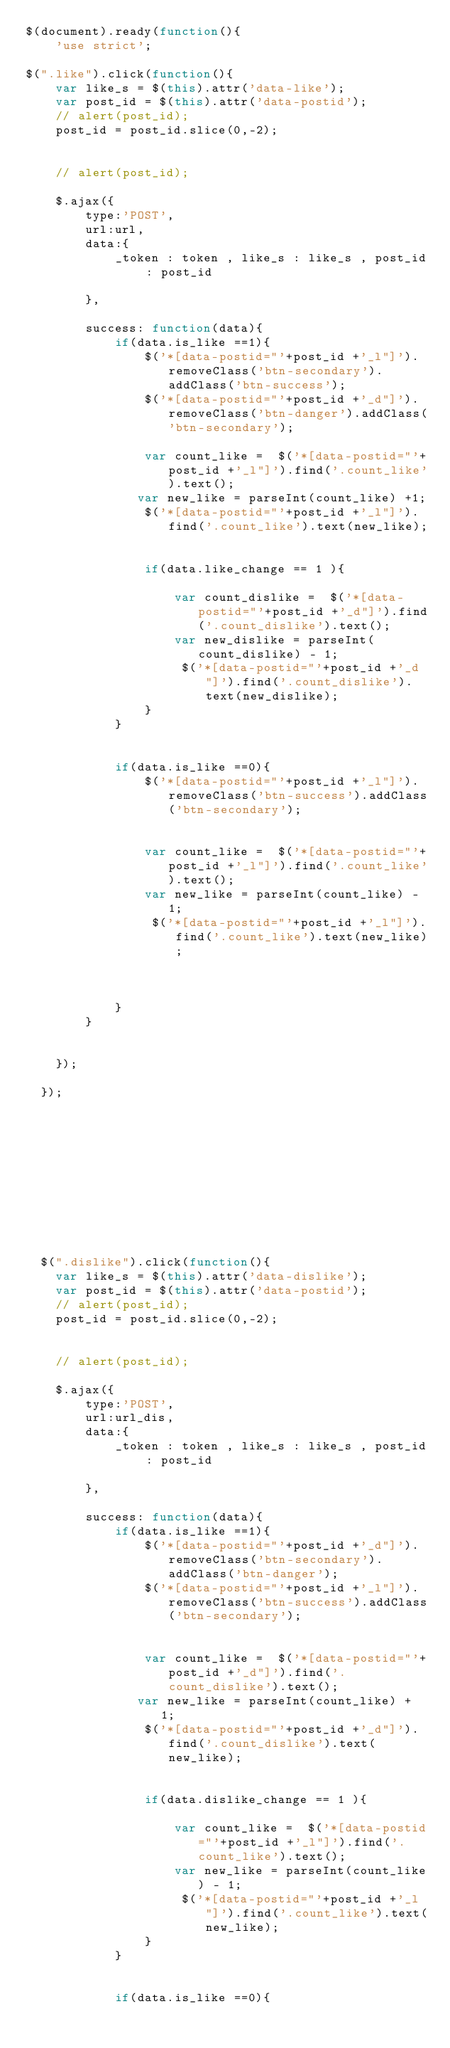<code> <loc_0><loc_0><loc_500><loc_500><_JavaScript_>$(document).ready(function(){
    'use strict';

$(".like").click(function(){
    var like_s = $(this).attr('data-like');
    var post_id = $(this).attr('data-postid');
    // alert(post_id);
    post_id = post_id.slice(0,-2);


    // alert(post_id);

    $.ajax({
        type:'POST',
        url:url,
        data:{
            _token : token , like_s : like_s , post_id : post_id

        },

        success: function(data){
            if(data.is_like ==1){
                $('*[data-postid="'+post_id +'_l"]').removeClass('btn-secondary').addClass('btn-success');
                $('*[data-postid="'+post_id +'_d"]').removeClass('btn-danger').addClass('btn-secondary');

                var count_like =  $('*[data-postid="'+post_id +'_l"]').find('.count_like').text();
               var new_like = parseInt(count_like) +1;
                $('*[data-postid="'+post_id +'_l"]').find('.count_like').text(new_like);


                if(data.like_change == 1 ){

                    var count_dislike =  $('*[data-postid="'+post_id +'_d"]').find('.count_dislike').text();
                    var new_dislike = parseInt(count_dislike) - 1;
                     $('*[data-postid="'+post_id +'_d"]').find('.count_dislike').text(new_dislike);
                }
            }


            if(data.is_like ==0){
                $('*[data-postid="'+post_id +'_l"]').removeClass('btn-success').addClass('btn-secondary');


                var count_like =  $('*[data-postid="'+post_id +'_l"]').find('.count_like').text();
                var new_like = parseInt(count_like) - 1;
                 $('*[data-postid="'+post_id +'_l"]').find('.count_like').text(new_like);



            }
        }


    });

  });











  $(".dislike").click(function(){
    var like_s = $(this).attr('data-dislike');
    var post_id = $(this).attr('data-postid');
    // alert(post_id);
    post_id = post_id.slice(0,-2);


    // alert(post_id);

    $.ajax({
        type:'POST',
        url:url_dis,
        data:{
            _token : token , like_s : like_s , post_id : post_id

        },

        success: function(data){
            if(data.is_like ==1){
                $('*[data-postid="'+post_id +'_d"]').removeClass('btn-secondary').addClass('btn-danger');
                $('*[data-postid="'+post_id +'_l"]').removeClass('btn-success').addClass('btn-secondary');


                var count_like =  $('*[data-postid="'+post_id +'_d"]').find('.count_dislike').text();
               var new_like = parseInt(count_like) + 1;
                $('*[data-postid="'+post_id +'_d"]').find('.count_dislike').text(new_like);


                if(data.dislike_change == 1 ){

                    var count_like =  $('*[data-postid="'+post_id +'_l"]').find('.count_like').text();
                    var new_like = parseInt(count_like) - 1;
                     $('*[data-postid="'+post_id +'_l"]').find('.count_like').text(new_like);
                }
            }


            if(data.is_like ==0){</code> 